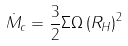<formula> <loc_0><loc_0><loc_500><loc_500>\dot { M } _ { c } = \frac { 3 } { 2 } \Sigma \Omega \left ( R _ { H } \right ) ^ { 2 }</formula> 